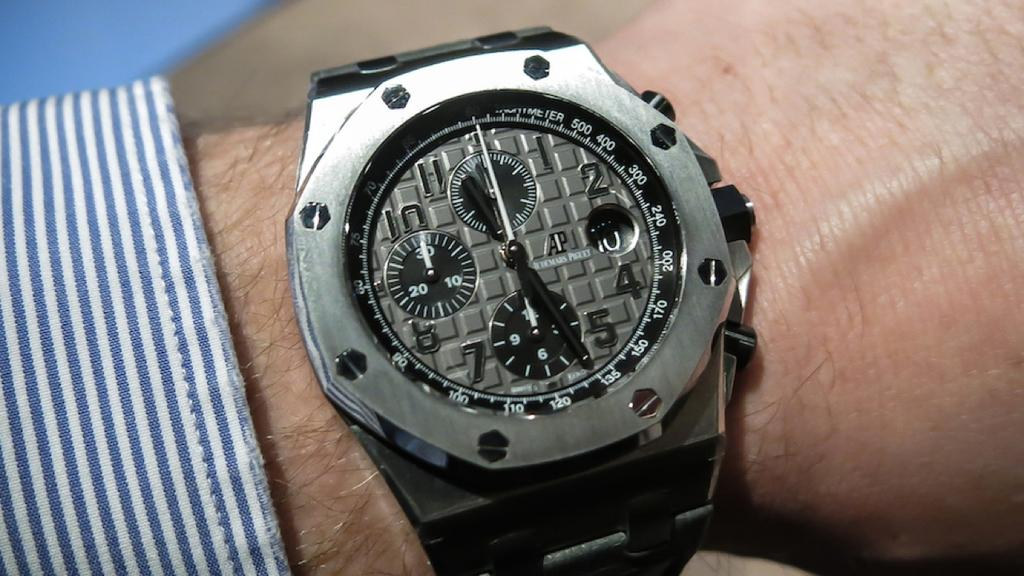What object can be seen on a person's hand in the image? There is a watch on a person's hand in the image. What part of clothing is visible in the image? The collar of a shirt is visible in the image. Is the person wearing a crown in the image? There is no crown visible in the image. Is the person in jail in the image? There is no indication of the person being in jail in the image. 